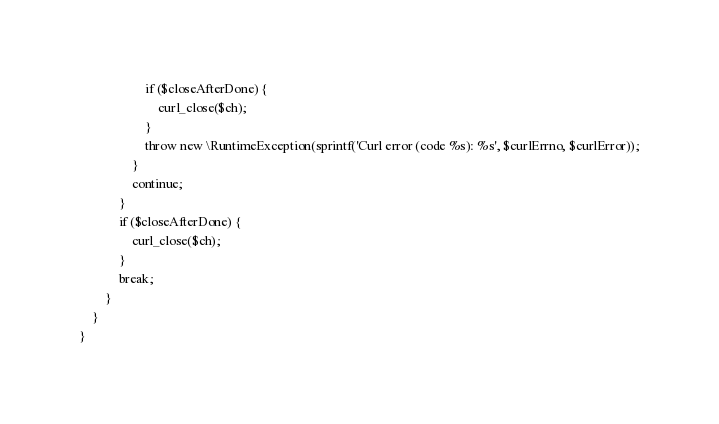<code> <loc_0><loc_0><loc_500><loc_500><_PHP_>                    if ($closeAfterDone) {
                        curl_close($ch);
                    }
                    throw new \RuntimeException(sprintf('Curl error (code %s): %s', $curlErrno, $curlError));
                }
                continue;
            }
            if ($closeAfterDone) {
                curl_close($ch);
            }
            break;
        }
    }
}
</code> 